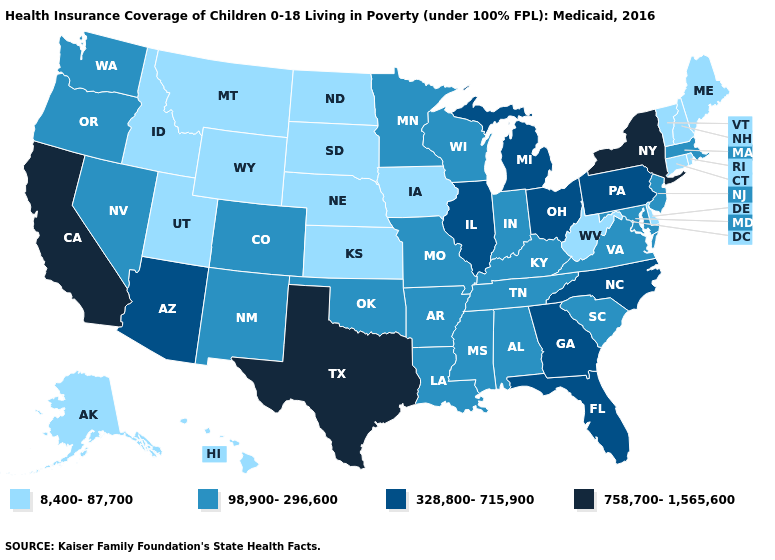How many symbols are there in the legend?
Give a very brief answer. 4. Among the states that border Connecticut , which have the lowest value?
Quick response, please. Rhode Island. Name the states that have a value in the range 758,700-1,565,600?
Quick response, please. California, New York, Texas. Does Nebraska have a higher value than Illinois?
Short answer required. No. Is the legend a continuous bar?
Quick response, please. No. Among the states that border South Carolina , which have the highest value?
Keep it brief. Georgia, North Carolina. What is the value of Oregon?
Quick response, please. 98,900-296,600. What is the highest value in states that border Florida?
Answer briefly. 328,800-715,900. Does the map have missing data?
Concise answer only. No. Among the states that border Georgia , which have the highest value?
Concise answer only. Florida, North Carolina. What is the value of Nevada?
Write a very short answer. 98,900-296,600. What is the highest value in the West ?
Be succinct. 758,700-1,565,600. Is the legend a continuous bar?
Keep it brief. No. Which states have the lowest value in the MidWest?
Concise answer only. Iowa, Kansas, Nebraska, North Dakota, South Dakota. 